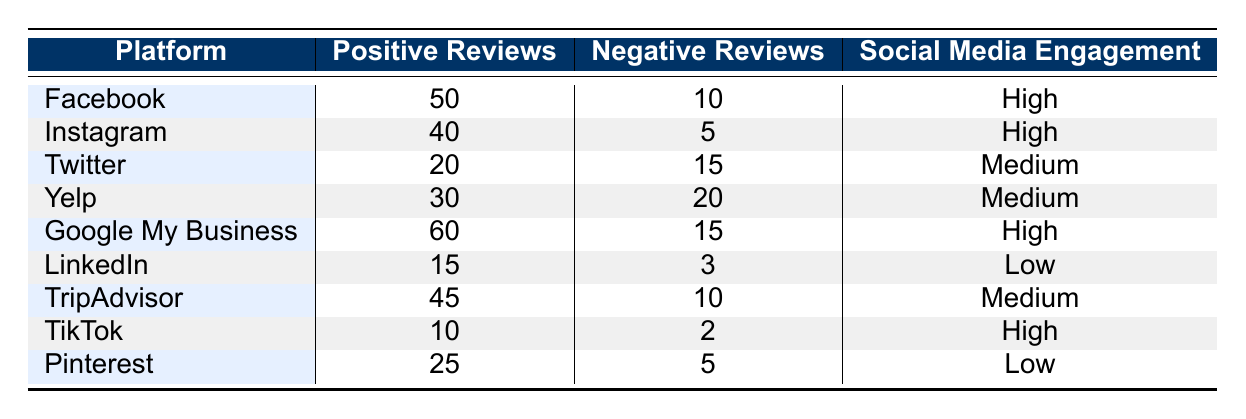What is the total number of positive reviews across all platforms? To find the total number of positive reviews, we sum the positive reviews for each platform: 50 (Facebook) + 40 (Instagram) + 20 (Twitter) + 30 (Yelp) + 60 (Google My Business) + 15 (LinkedIn) + 45 (TripAdvisor) + 10 (TikTok) + 25 (Pinterest) = 350.
Answer: 350 What is the highest number of negative reviews on a single platform? Looking at the table, the highest number of negative reviews is found in Yelp, which has 20 negative reviews.
Answer: 20 Are there any platforms with high social media engagement that have negative reviews? Yes, Facebook, Instagram, Google My Business, and TikTok all have high social media engagement, and they do have some negative reviews (10, 5, 15, and 2 respectively).
Answer: Yes What is the average number of negative reviews for platforms with medium social media engagement? The platforms with medium engagement are Twitter, Yelp, and TripAdvisor. Their negative reviews are 15 (Twitter) + 20 (Yelp) + 10 (TripAdvisor) = 45. There are 3 platforms, so the average is 45/3 = 15.
Answer: 15 What is the difference between the total positive reviews for high and low engagement platforms? First, we sum positive reviews for high engagement (Facebook - 50, Instagram - 40, Google My Business - 60, TikTok - 10): 50 + 40 + 60 + 10 = 160. For low engagement (LinkedIn - 15, Pinterest - 25): 15 + 25 = 40. The difference is 160 - 40 = 120.
Answer: 120 